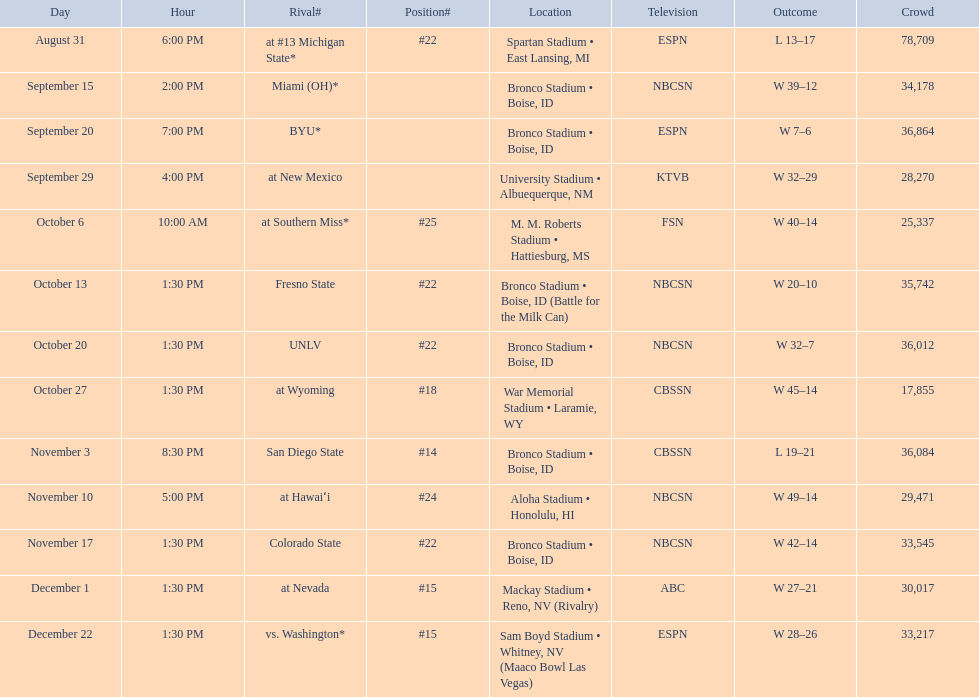Who were all of the opponents? At #13 michigan state*, miami (oh)*, byu*, at new mexico, at southern miss*, fresno state, unlv, at wyoming, san diego state, at hawaiʻi, colorado state, at nevada, vs. washington*. Who did they face on november 3rd? San Diego State. What rank were they on november 3rd? #14. 